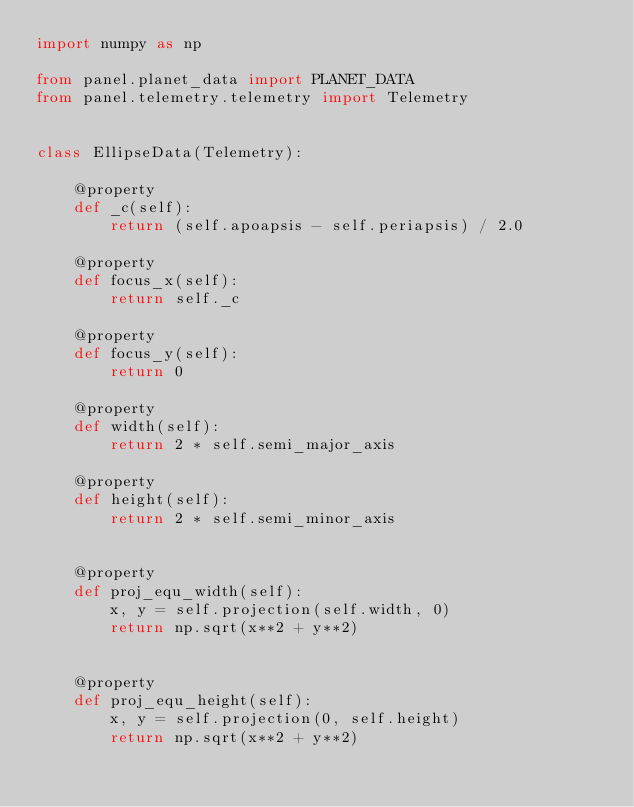<code> <loc_0><loc_0><loc_500><loc_500><_Python_>import numpy as np

from panel.planet_data import PLANET_DATA
from panel.telemetry.telemetry import Telemetry


class EllipseData(Telemetry):

    @property
    def _c(self):
        return (self.apoapsis - self.periapsis) / 2.0

    @property
    def focus_x(self):
        return self._c

    @property
    def focus_y(self):
        return 0

    @property
    def width(self):
        return 2 * self.semi_major_axis

    @property
    def height(self):
        return 2 * self.semi_minor_axis


    @property
    def proj_equ_width(self):
        x, y = self.projection(self.width, 0)
        return np.sqrt(x**2 + y**2)


    @property
    def proj_equ_height(self):
        x, y = self.projection(0, self.height)
        return np.sqrt(x**2 + y**2)
</code> 